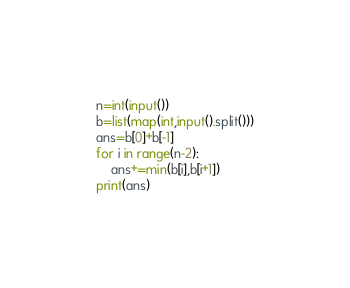<code> <loc_0><loc_0><loc_500><loc_500><_Python_>n=int(input())
b=list(map(int,input().split()))
ans=b[0]+b[-1]
for i in range(n-2):
    ans+=min(b[i],b[i+1])
print(ans)</code> 